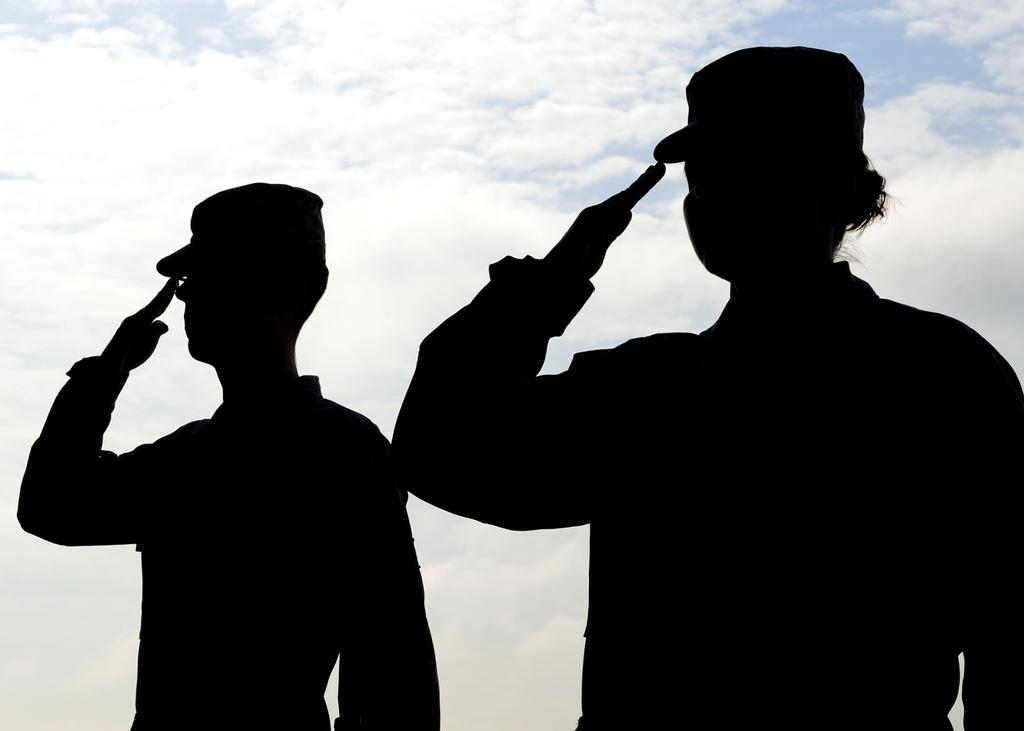How many people are present in the image? There are two persons in the image. What is visible in the background of the image? The sky is visible in the image. What language are the two persons discussing in the image? There is no information about the language being used in the image. How comfortable are the two persons in the image? There is no information about the comfort level of the two persons in the image. 